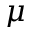Convert formula to latex. <formula><loc_0><loc_0><loc_500><loc_500>\mu</formula> 